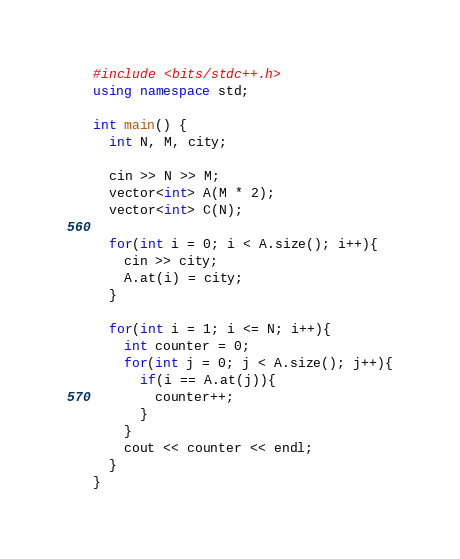<code> <loc_0><loc_0><loc_500><loc_500><_C++_>#include <bits/stdc++.h>
using namespace std;

int main() {
  int N, M, city;
  
  cin >> N >> M;
  vector<int> A(M * 2);
  vector<int> C(N);

  for(int i = 0; i < A.size(); i++){
    cin >> city;
    A.at(i) = city;
  }

  for(int i = 1; i <= N; i++){
    int counter = 0;
    for(int j = 0; j < A.size(); j++){
      if(i == A.at(j)){
        counter++;
      }
    }
    cout << counter << endl;
  }
}</code> 